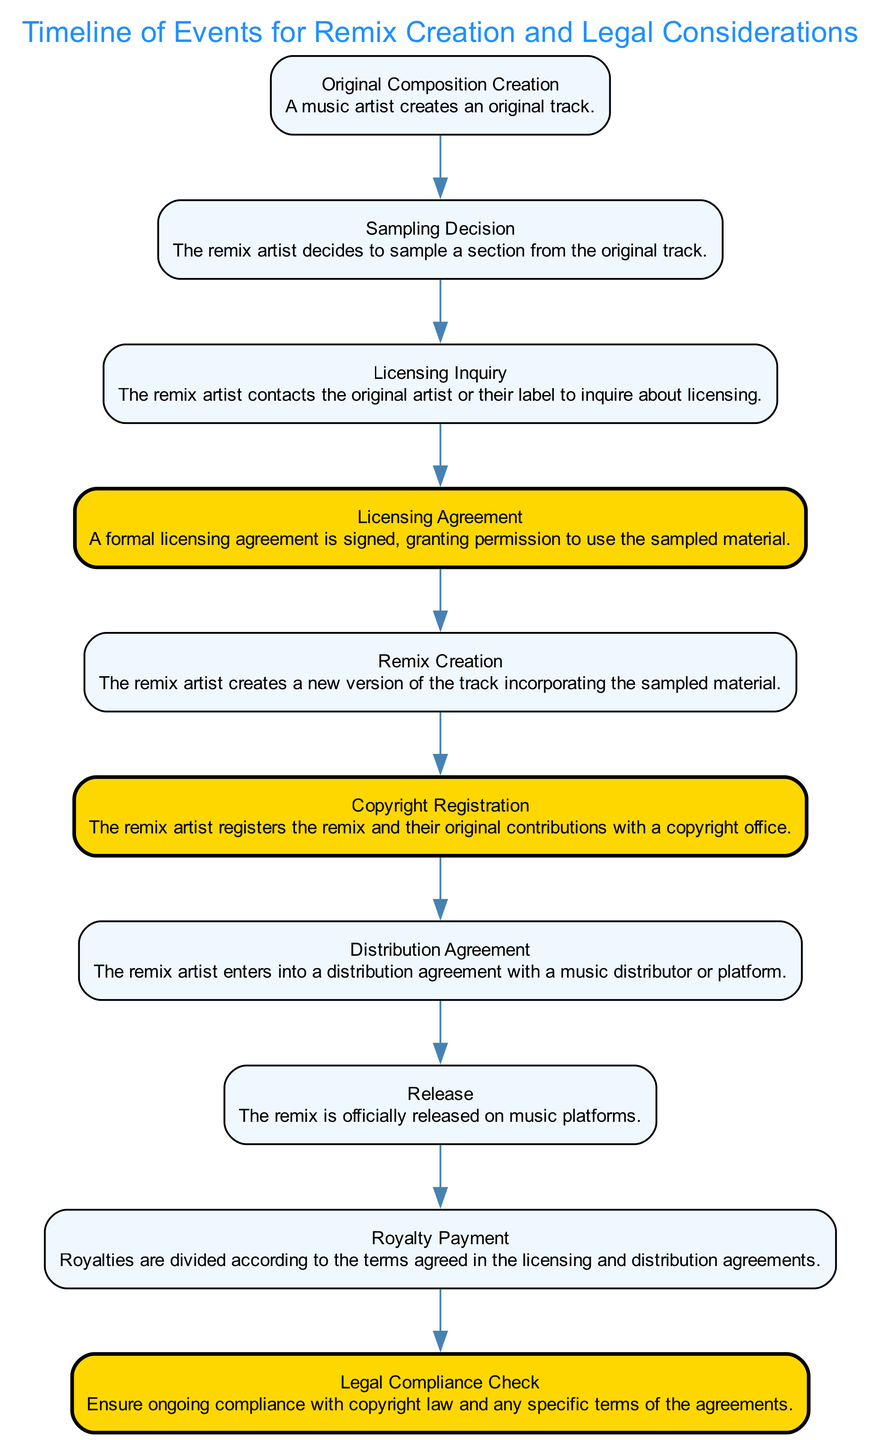What is the first event in the timeline? The first event listed in the sequence is "Original Composition Creation," where a music artist creates an original track.
Answer: Original Composition Creation How many total events are in the diagram? By counting each distinct event in the sequence, there are ten events listed.
Answer: 10 What event follows the "Sampling Decision"? According to the sequence of events, the event that follows "Sampling Decision" is "Licensing Inquiry."
Answer: Licensing Inquiry Which event marks the formal permission to use sampled material? The "Licensing Agreement" event signifies the signing of a formal agreement granting permission to use the sampled material.
Answer: Licensing Agreement What legal step involves registering the remix? The event labeled "Copyright Registration" indicates that the remix artist registers their work officially.
Answer: Copyright Registration How many legal steps are highlighted in the diagram? The diagram highlights three legal steps, which are "Licensing Agreement," "Copyright Registration," and "Legal Compliance Check."
Answer: 3 What is the last event in the timeline? The final event in the timeline is "Legal Compliance Check," which ensures ongoing compliance with the laws and agreements.
Answer: Legal Compliance Check In what phase does the remix artist create their track? The remix artist creates the track during the event labeled "Remix Creation," where they incorporate the sampled material.
Answer: Remix Creation What event indicates the official release of the remix? The event that indicates the official release is simply titled "Release," where the remix becomes available on music platforms.
Answer: Release 